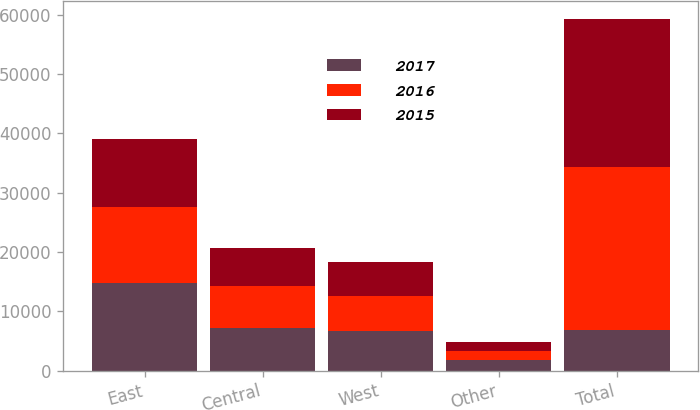<chart> <loc_0><loc_0><loc_500><loc_500><stacked_bar_chart><ecel><fcel>East<fcel>Central<fcel>West<fcel>Other<fcel>Total<nl><fcel>2017<fcel>14775<fcel>7154<fcel>6715<fcel>1704<fcel>6878<nl><fcel>2016<fcel>12764<fcel>7041<fcel>5910<fcel>1657<fcel>27372<nl><fcel>2015<fcel>11579<fcel>6448<fcel>5608<fcel>1471<fcel>25106<nl></chart> 